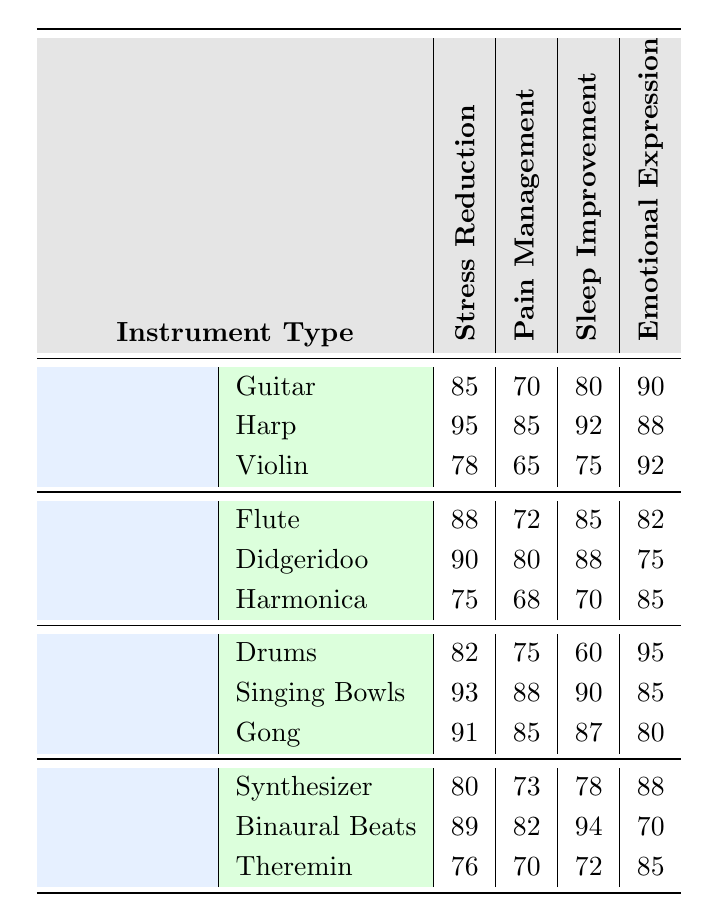What is the effectiveness of the Harp in Stress Reduction? The effectiveness of the Harp in Stress Reduction is given as 95 in the table.
Answer: 95 Which instrument has the lowest score in Pain Management? The Violin has the lowest score in Pain Management at 65 compared to all the instruments listed in the table.
Answer: Violin What are the average scores for Sleep Improvement across all instrument types? The scores for Sleep Improvement are: Guitar (80), Harp (92), Violin (75), Flute (85), Didgeridoo (88), Harmonica (70), Drums (60), Singing Bowls (90), Gong (87), Synthesizer (78), Binaural Beats (94), Theremin (72). The average is calculated as (80 + 92 + 75 + 85 + 88 + 70 + 60 + 90 + 87 + 78 + 94 + 72) / 12 = 80.25.
Answer: 80.25 Is the effectiveness of the Singing Bowls higher in Emotional Expression or Stress Reduction? The effectiveness of Singing Bowls is 95 in Emotional Expression and 93 in Stress Reduction. Since 95 is greater than 93, Singing Bowls are more effective in Emotional Expression.
Answer: Yes Which instrument category has the highest average for Pain Management? The Pain Management scores by category are: Stringed (75), Wind (73.33), Percussion (82), and Electronic (75). The Percussion category has the highest score at 82.
Answer: Percussion Overall, what instrument is the best for Stress Reduction? Comparing the Stress Reduction scores, the Harp has the highest score of 95 among all instruments.
Answer: Harp What is the difference in effectiveness for Emotional Expression between Drums and Didgeridoo? The Emotional Expression score for Drums is 95 and for Didgeridoo is 75. The difference is calculated as 95 - 75 = 20.
Answer: 20 Which wind instrument provides the least Sleep Improvement? The Harmonica provides the least Sleep Improvement, with a score of 70, compared to all other wind instruments.
Answer: Harmonica Are synthetic sound therapies like Synthesizer and Binaural Beats effective in Stress Reduction? The scores show Synthesizer at 80 and Binaural Beats at 89 for Stress Reduction. Both scores indicate effectiveness, with Binaural Beats being more effective.
Answer: Yes What is the highest overall score for Pain Management from the Percussion category? The highest score for Pain Management from the Percussion category is 88 by Singing Bowls.
Answer: 88 